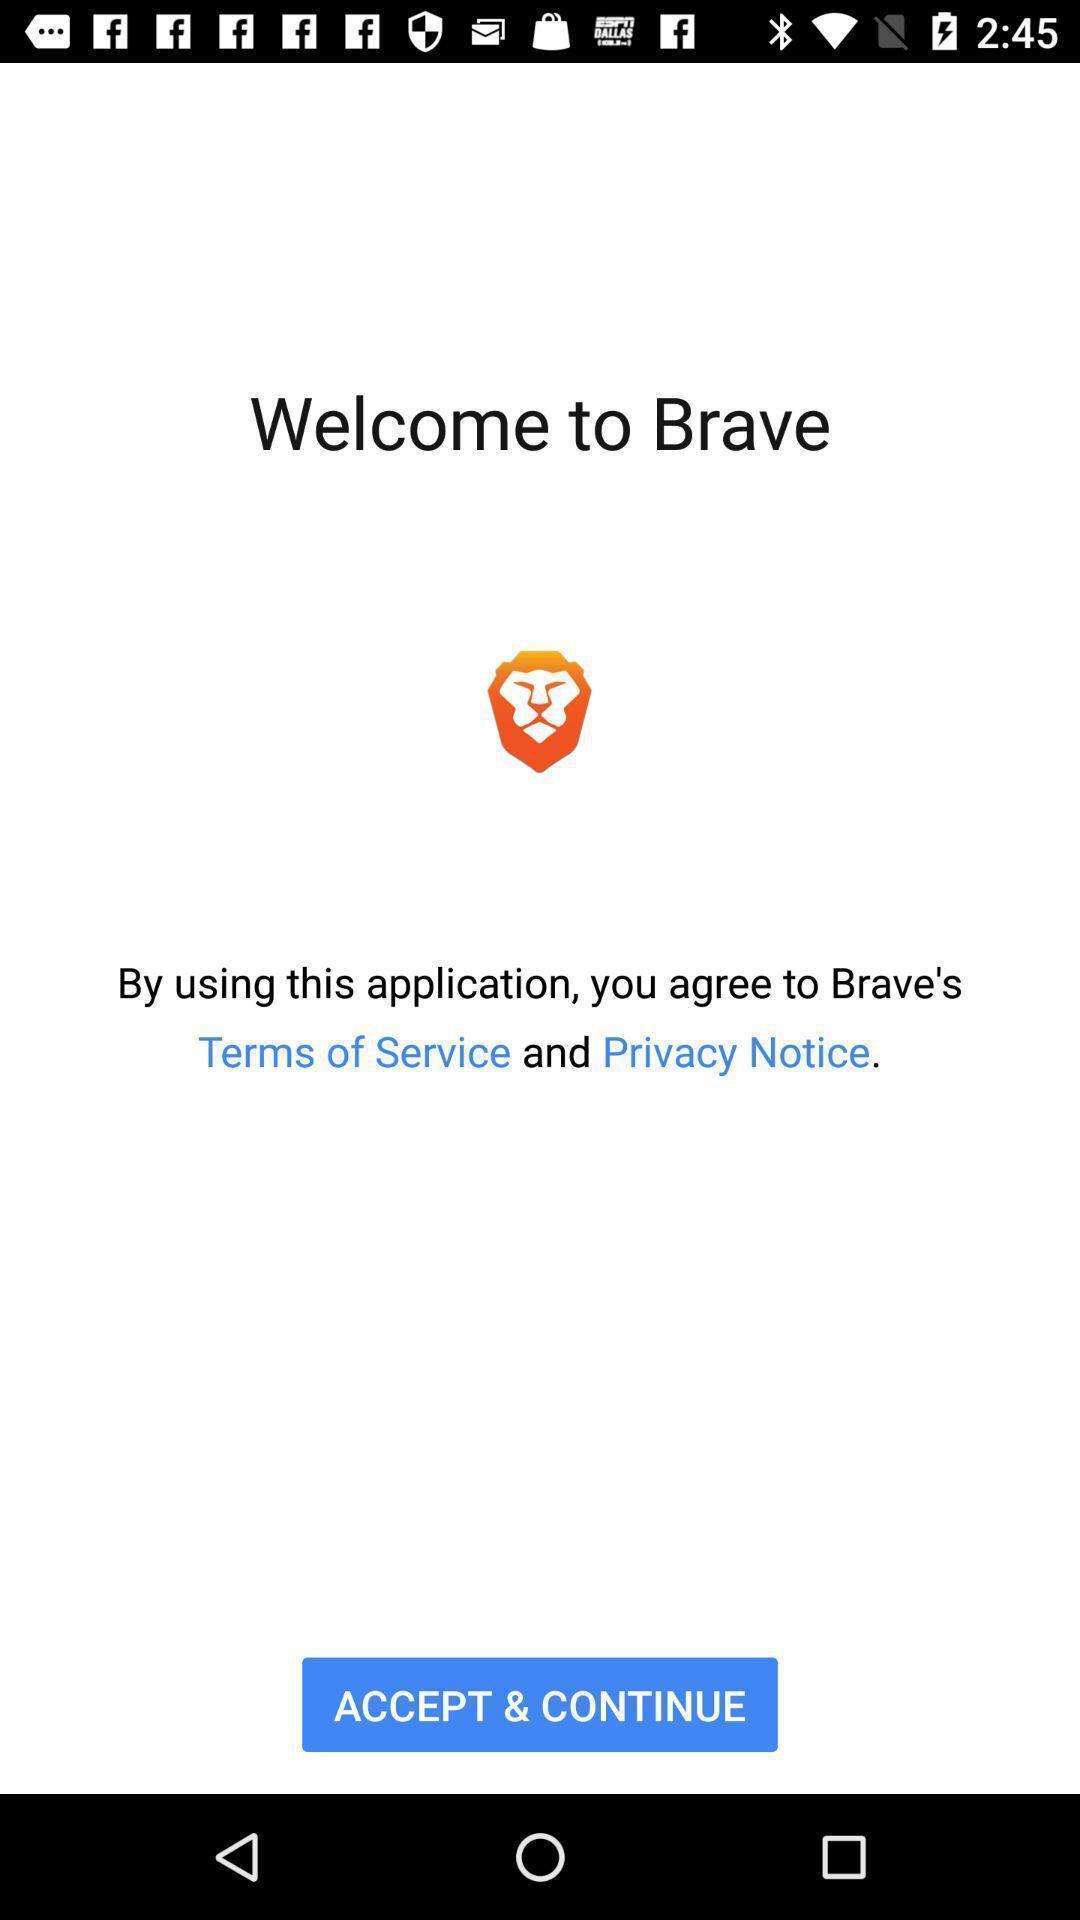Give me a summary of this screen capture. Welcome page showing declaration details to accept. 